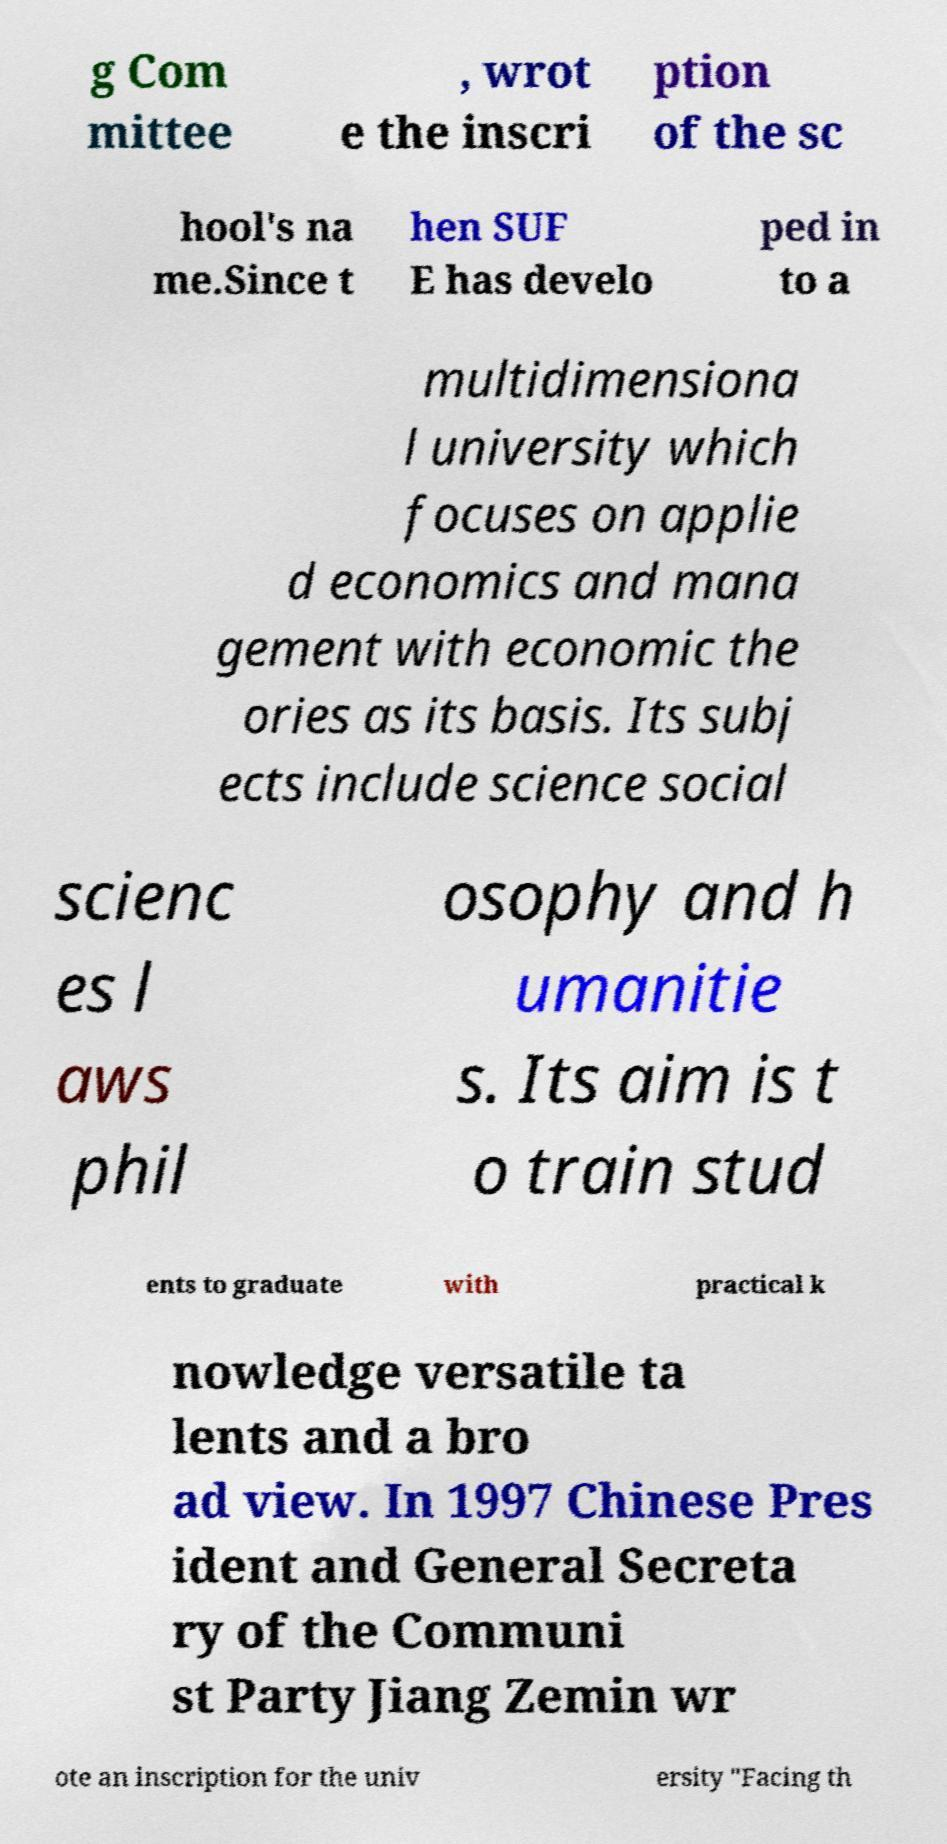I need the written content from this picture converted into text. Can you do that? g Com mittee , wrot e the inscri ption of the sc hool's na me.Since t hen SUF E has develo ped in to a multidimensiona l university which focuses on applie d economics and mana gement with economic the ories as its basis. Its subj ects include science social scienc es l aws phil osophy and h umanitie s. Its aim is t o train stud ents to graduate with practical k nowledge versatile ta lents and a bro ad view. In 1997 Chinese Pres ident and General Secreta ry of the Communi st Party Jiang Zemin wr ote an inscription for the univ ersity "Facing th 